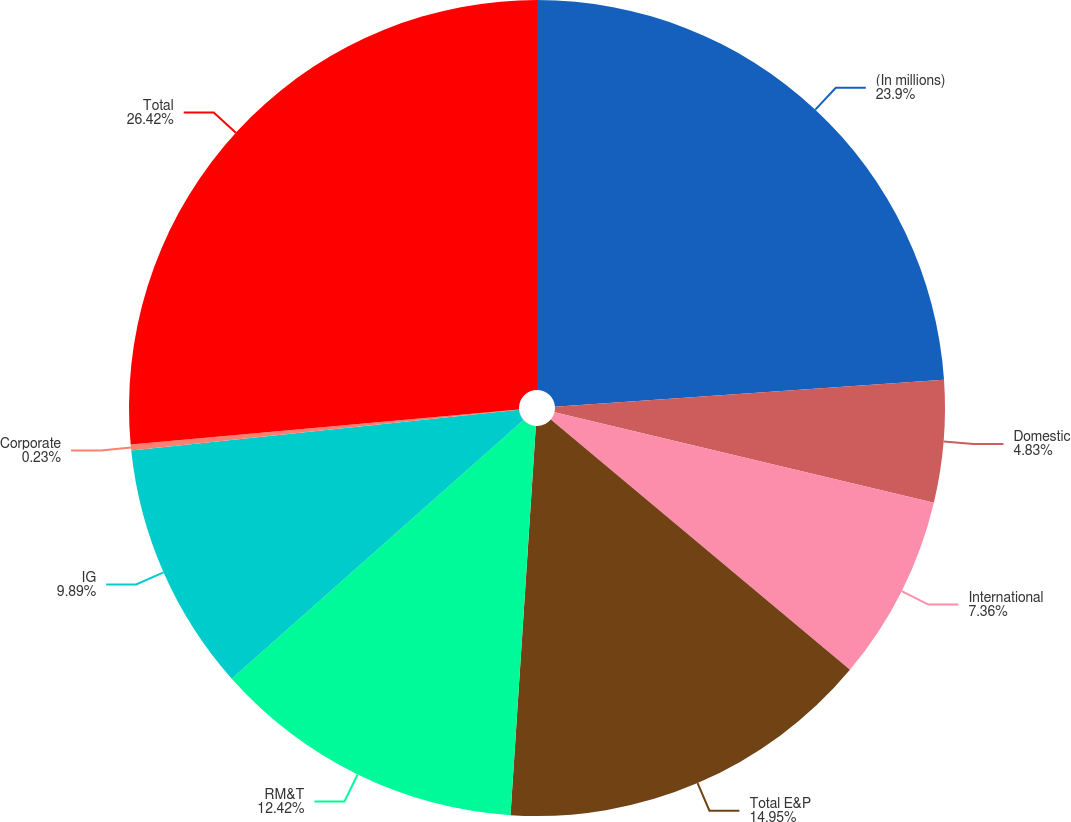Convert chart to OTSL. <chart><loc_0><loc_0><loc_500><loc_500><pie_chart><fcel>(In millions)<fcel>Domestic<fcel>International<fcel>Total E&P<fcel>RM&T<fcel>IG<fcel>Corporate<fcel>Total<nl><fcel>23.9%<fcel>4.83%<fcel>7.36%<fcel>14.95%<fcel>12.42%<fcel>9.89%<fcel>0.23%<fcel>26.43%<nl></chart> 